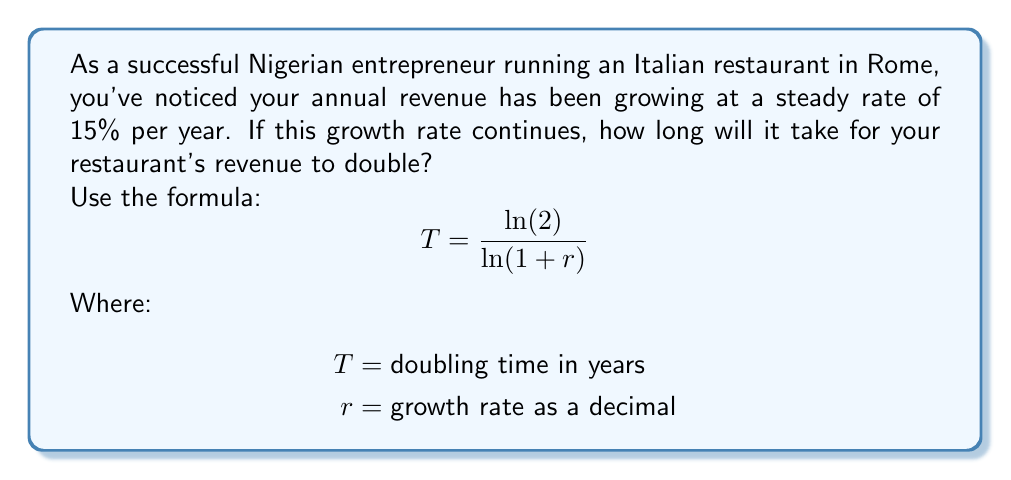Can you solve this math problem? To solve this problem, we'll use the doubling time formula:

$$T = \frac{\ln(2)}{\ln(1 + r)}$$

Where:
$T$ = doubling time in years
$r$ = growth rate as a decimal

Given:
- Growth rate = 15% per year = 0.15

Step 1: Substitute the growth rate into the formula:
$$T = \frac{\ln(2)}{\ln(1 + 0.15)}$$

Step 2: Calculate the denominator:
$$\ln(1 + 0.15) = \ln(1.15) \approx 0.1398$$

Step 3: Calculate the final result:
$$T = \frac{\ln(2)}{0.1398} \approx \frac{0.6931}{0.1398} \approx 4.959$$

Step 4: Round to two decimal places:
$$T \approx 4.96$$

Therefore, it will take approximately 4.96 years for your restaurant's revenue to double at a 15% annual growth rate.
Answer: 4.96 years 